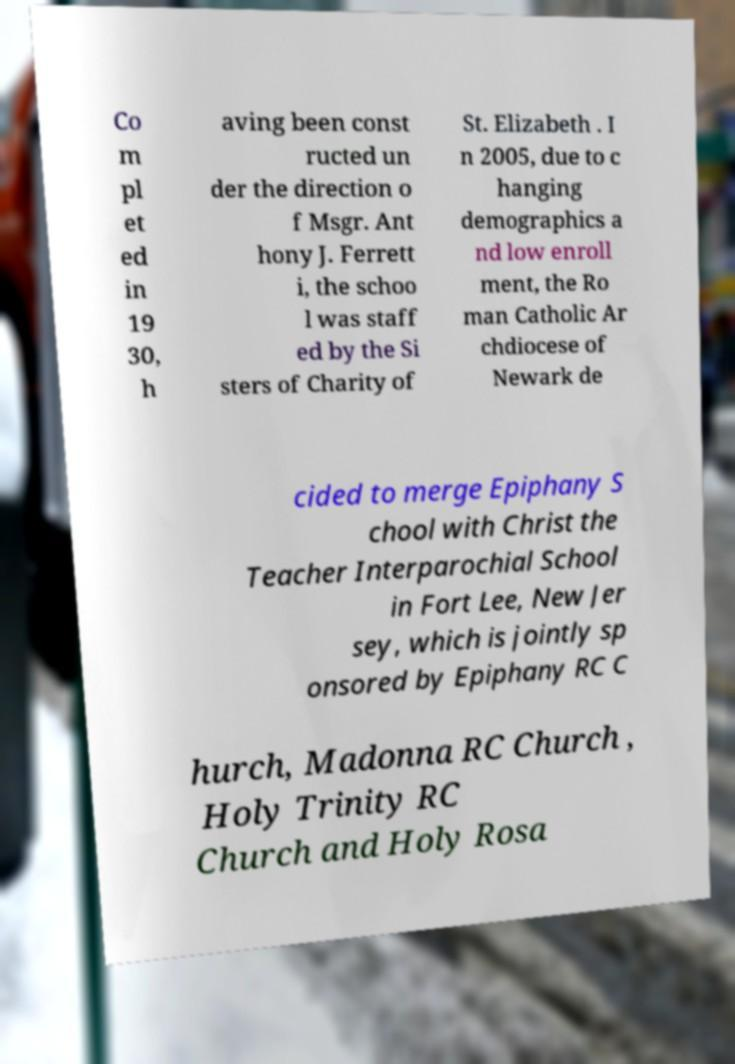Could you assist in decoding the text presented in this image and type it out clearly? Co m pl et ed in 19 30, h aving been const ructed un der the direction o f Msgr. Ant hony J. Ferrett i, the schoo l was staff ed by the Si sters of Charity of St. Elizabeth . I n 2005, due to c hanging demographics a nd low enroll ment, the Ro man Catholic Ar chdiocese of Newark de cided to merge Epiphany S chool with Christ the Teacher Interparochial School in Fort Lee, New Jer sey, which is jointly sp onsored by Epiphany RC C hurch, Madonna RC Church , Holy Trinity RC Church and Holy Rosa 